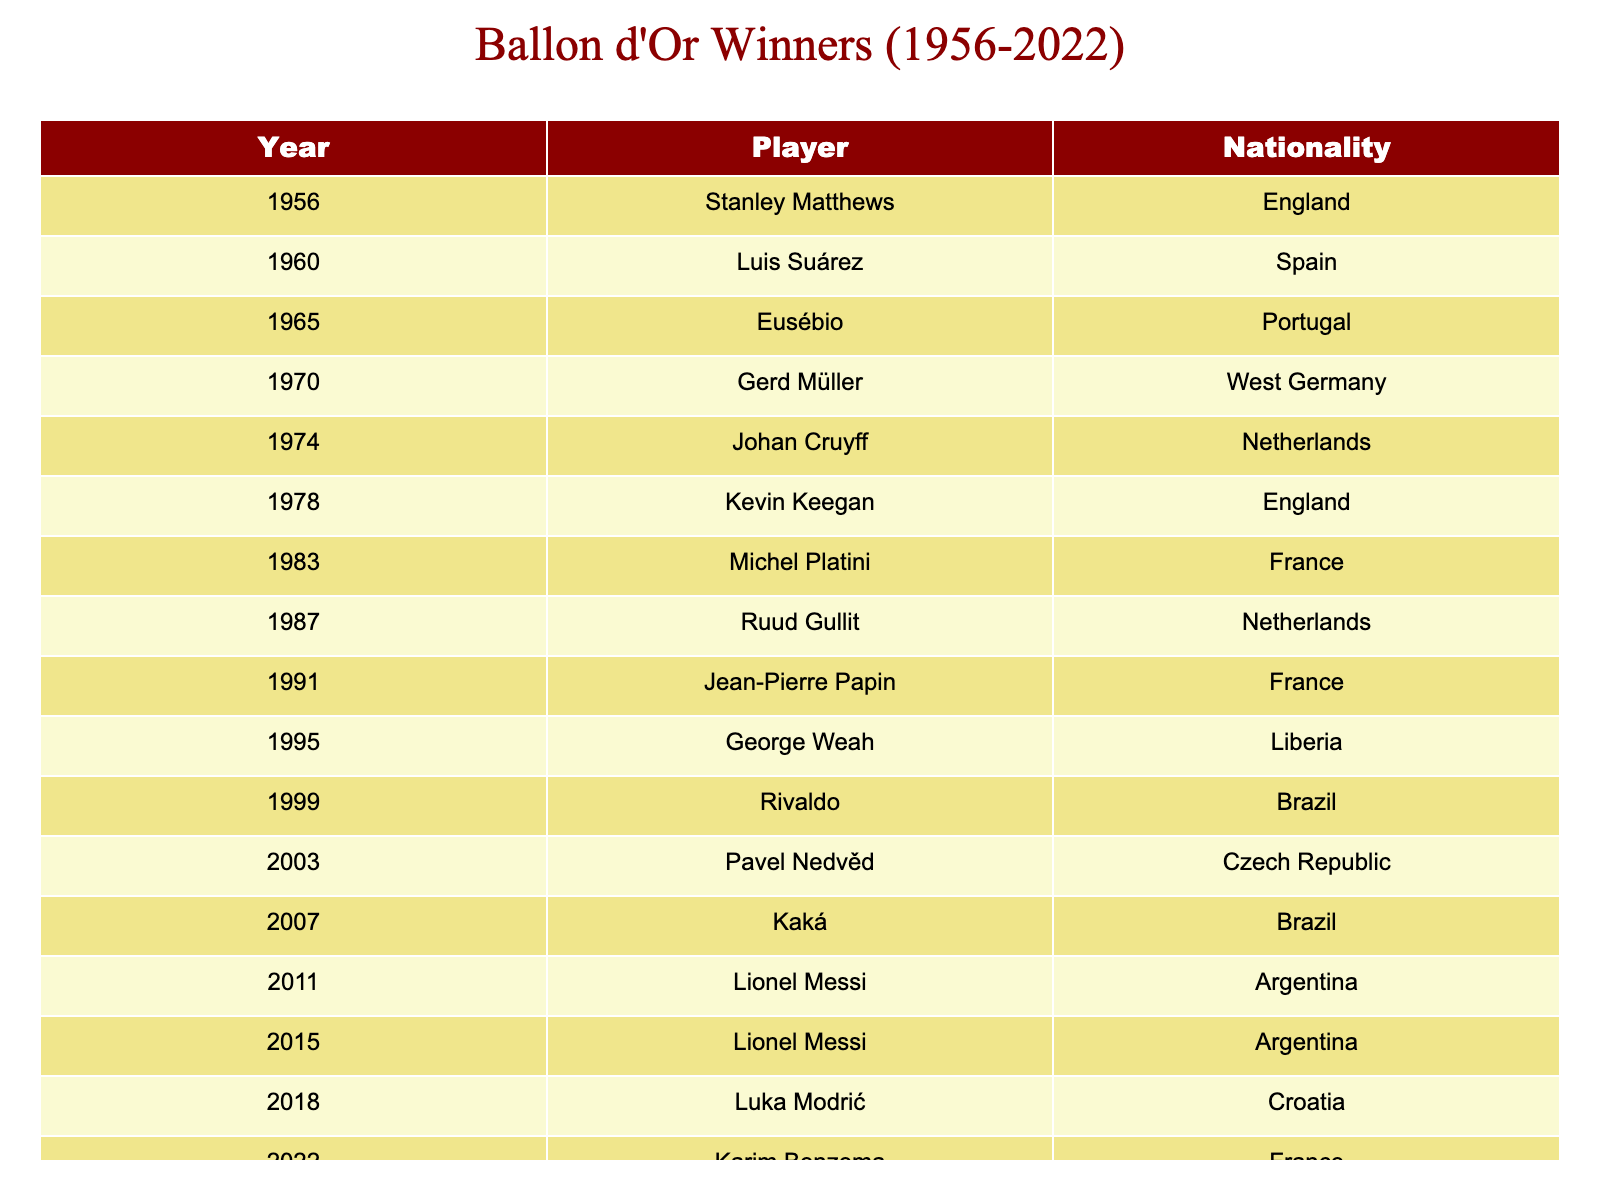What's the nationality of the 1995 Ballon d'Or winner? The table lists George Weah as the 1995 winner, and his nationality is Liberia as shown in the corresponding row of the table.
Answer: Liberia How many players won the Ballon d'Or from Brazil? The table shows that there are two Brazilian winners: Rivaldo in 1999 and Kaká in 2007, so we count these two instances.
Answer: 2 Who won the Ballon d'Or in the year 2003? Looking at the table, Pavel Nedvěd is listed as the winner for the year 2003.
Answer: Pavel Nedvěd Which nationality has the most Ballon d'Or winners based on this table? By inspecting the table closely, we can see that players from France have won the award three times (Michel Platini in 1983, Jean-Pierre Papin in 1991, and Karim Benzema in 2022). No nationality has more than this count in the provided data.
Answer: France Was there any Ballon d'Or winner from the Czech Republic? The table provides the information that Pavel Nedvěd won the Ballon d'Or in 2003, and he is listed as being from the Czech Republic, confirming this fact.
Answer: Yes Which years did Lionel Messi win the Ballon d'Or? The table indicates that Lionel Messi won the award in 2011 and 2015, as he appears in both rows with those corresponding years.
Answer: 2011, 2015 What is the average year of Ballon d'Or wins for players from England? The table shows that Kevin Keegan (1978) and Stanley Matthews (1956) are the two winners from England. To find the average, we calculate (1978 + 1956) / 2 = 1967.
Answer: 1967 How many unique nationalities are represented among the Ballon d'Or winners from this table? By examining the table, we find that there are 12 different nationalities listed for the winners over the years, so we can count them accurately.
Answer: 12 What was the difference in years between the first Ballon d'Or winner and the most recent one listed? The first winner, Stanley Matthews, won in 1956, and the most recent winner, Karim Benzema, won in 2022. The difference in years is calculated as 2022 - 1956 = 66.
Answer: 66 Did any player from the Netherlands win the Ballon d'Or more than once? The table shows that Johan Cruyff won in 1974 and Ruud Gullit won in 1987, indicating no player from the Netherlands won multiple times according to this data.
Answer: No 